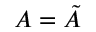Convert formula to latex. <formula><loc_0><loc_0><loc_500><loc_500>A = { \tilde { A } }</formula> 